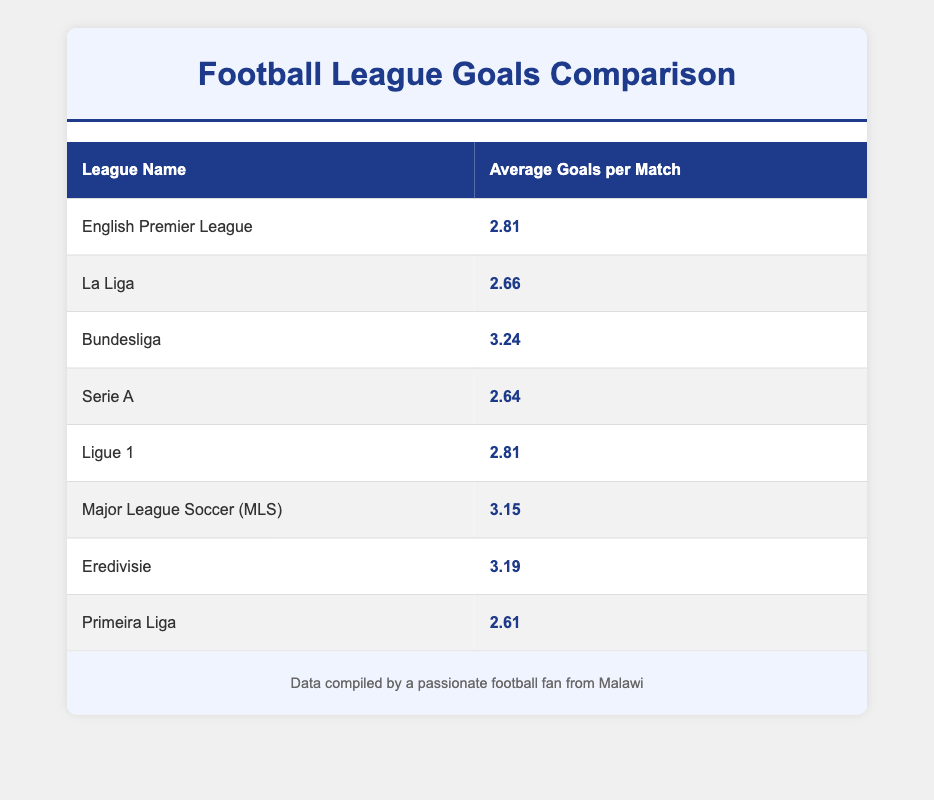What is the average goals per match in Bundesliga? The Bundesliga's average goals per match is listed in the table under its respective row, which shows a value of 3.24.
Answer: 3.24 How does the average goals per match in Serie A compare to Primeira Liga? The average for Serie A is 2.64, while Primeira Liga has an average of 2.61. Comparing these two values shows that Serie A scores slightly more goals per match than Primeira Liga.
Answer: Serie A has more goals per match Which league has the highest average goals per match? By examining the averages in the table, the Bundesliga stands out with the highest average at 3.24 goals per match, confirming it as the highest among all listed leagues.
Answer: Bundesliga What is the total average goals per match for English Premier League and Ligue 1 combined? The average for English Premier League is 2.81, and for Ligue 1, it is also 2.81. Adding these two values: 2.81 + 2.81 = 5.62. Thus, the combined average is 5.62.
Answer: 5.62 Is the average goals scored per match in Major League Soccer greater than that in La Liga? The average for Major League Soccer is 3.15, and for La Liga, it is 2.66. Since 3.15 is greater than 2.66, the statement is indeed true.
Answer: Yes Which leagues have an average of less than 2.70 goals per match? Checking the table, Serie A (2.64) and Primeira Liga (2.61) are the only leagues with an average below 2.70. This requires filtering the table for values less than 2.70.
Answer: Serie A and Primeira Liga What is the difference in average goals per match between Bundesliga and Eredivisie? The average goals per match for Bundesliga is 3.24, and for Eredivisie, it is 3.19. Subtracting these two: 3.24 - 3.19 = 0.05 shows that Bundesliga has 0.05 more average goals per match than Eredivisie.
Answer: 0.05 Which leagues have the same average goals per match? Observing the table, both the English Premier League and Ligue 1 have an average of 2.81. Therefore, these two leagues can be considered equal in this regard.
Answer: English Premier League and Ligue 1 